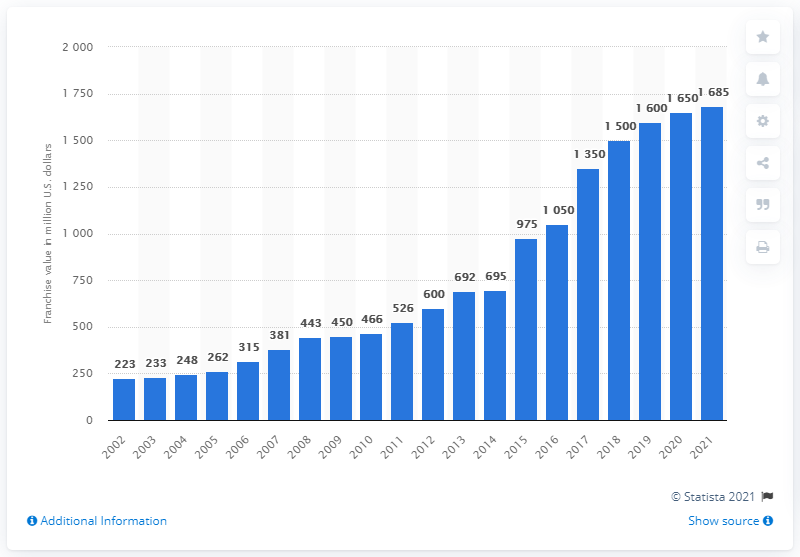Identify some key points in this picture. The estimated value of the Chicago White Sox in 2021 was approximately 1,685. 